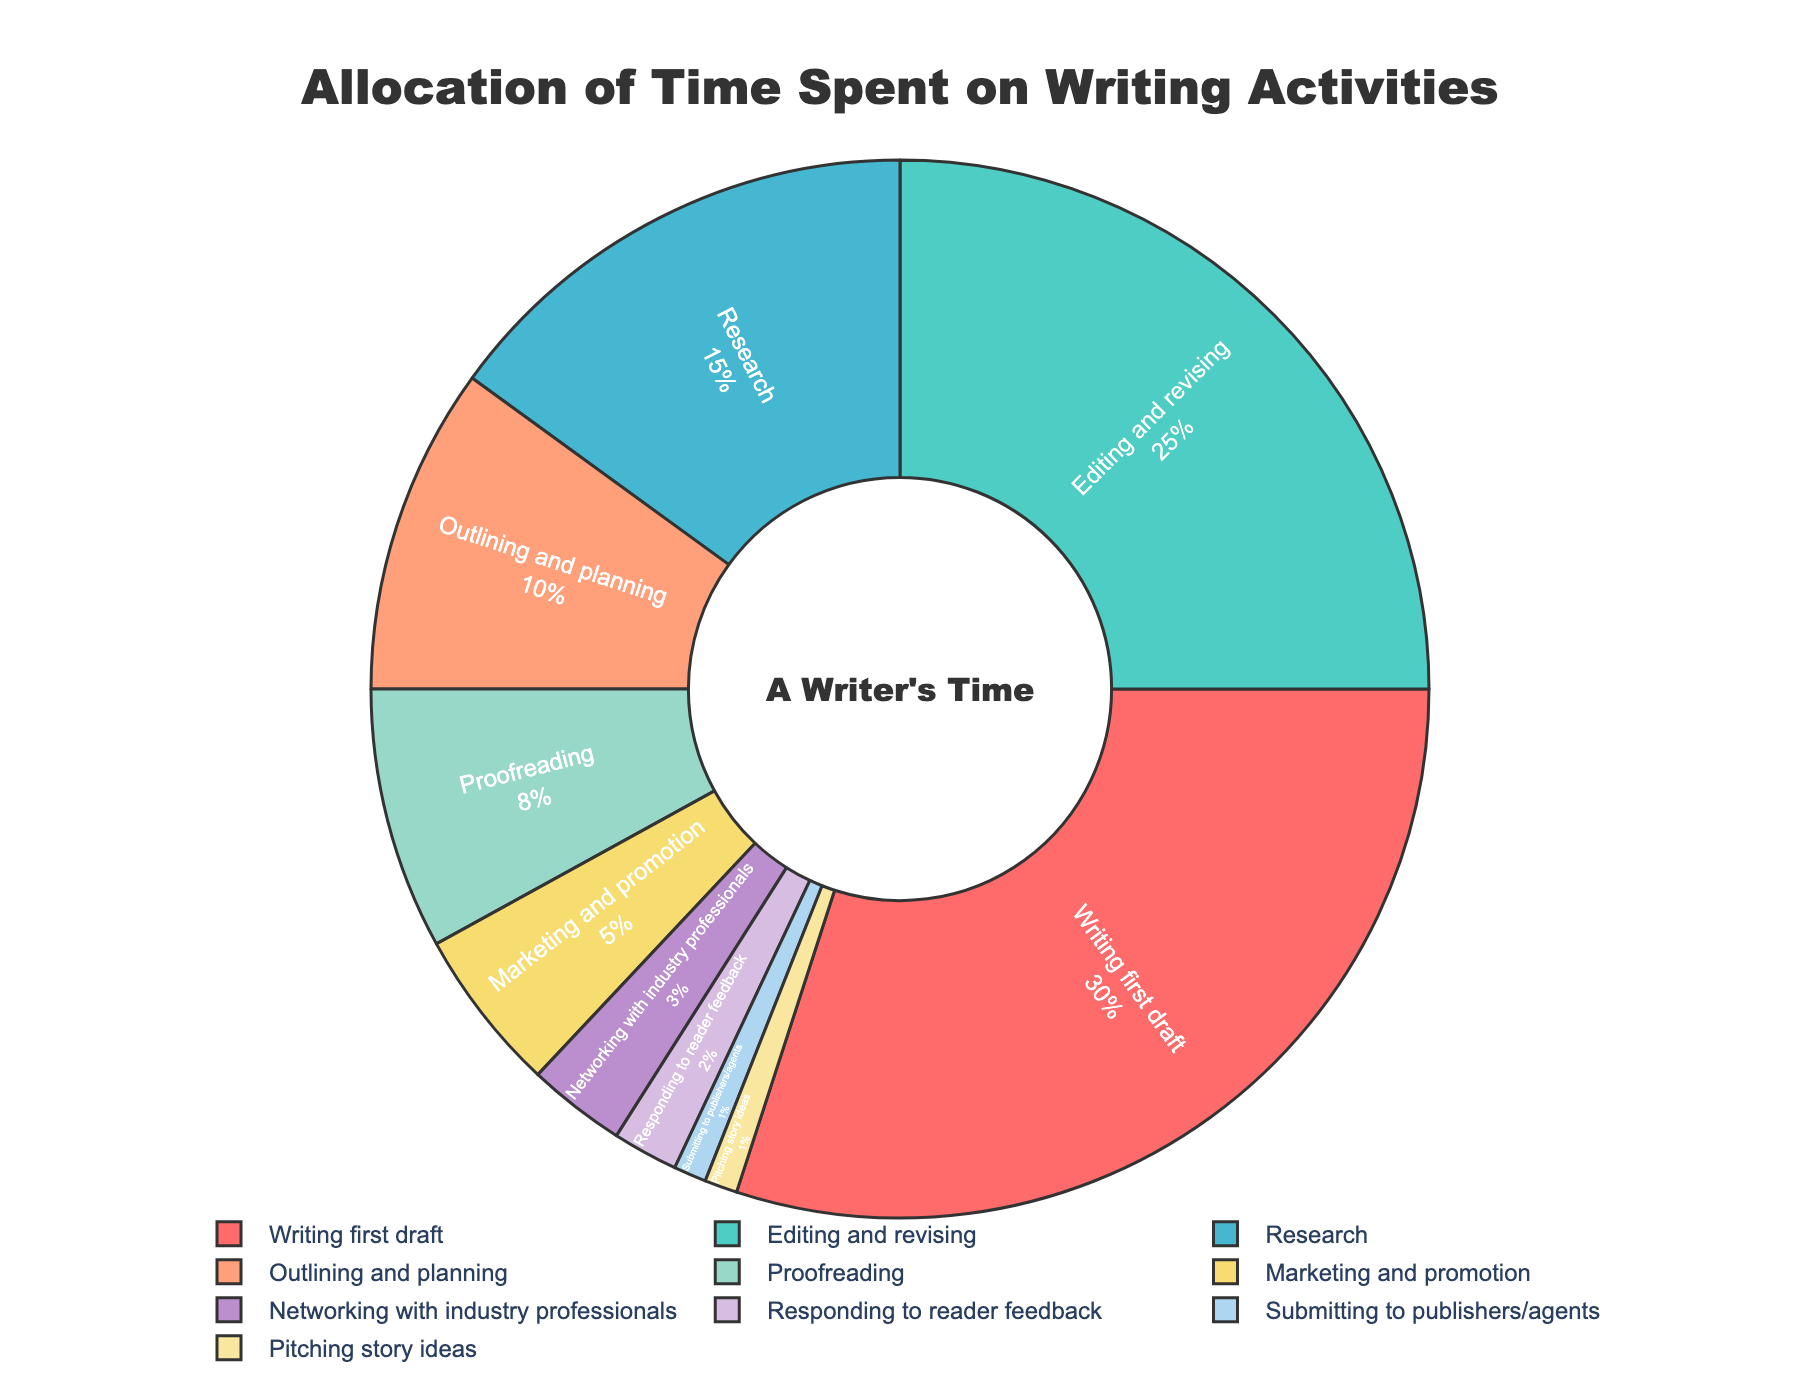What is the largest portion of the pie chart representing? The largest portion of the pie chart represents "Writing first draft," which takes up 30% of the total time.
Answer: Writing first draft Which activity takes up a quarter of the time? "Editing and revising" takes up 25% of the total time. This is 25%, which is one-quarter of 100%.
Answer: Editing and revising How much more time is spent on editing and revising compared to marketing and promotion? The percentage of time spent on editing and revising is 25%, and on marketing and promotion is 5%. The difference is 25% - 5% = 20%.
Answer: 20% Which activities together take up the same amount of time as writing the first draft? "Editing and revising" (25%) plus "Networking with industry professionals" (3%) and "Responding to reader feedback" (2%) together take up 25% + 3% + 2% = 30%, which is equal to the time spent on writing the first draft.
Answer: Editing and revising, Networking with industry professionals, and Responding to reader feedback What percentage of the pie chart is dedicated to research and planning activities combined? "Research" takes up 15%, and "Outlining and planning" takes up 10%. Combined, they take up 15% + 10% = 25%.
Answer: 25% Which activities are represented by the smallest segments of the pie chart? The smallest segments of the pie chart represent "Submitting to publishers/agents" and "Pitching story ideas," each with 1%.
Answer: Submitting to publishers/agents and Pitching story ideas Is the time spent on proofreading more or less than the time spent on marketing and promotion? The time spent on proofreading (8%) is more than the time spent on marketing and promotion (5%).
Answer: More List the activities that combined are less than the time spent on proofreading. "Networking with industry professionals" (3%), "Responding to reader feedback" (2%), "Submitting to publishers/agents" (1%), and "Pitching story ideas" (1%) combined make up 3% + 2% + 1% + 1% = 7%, which is less than the 8% spent on proofreading.
Answer: Networking with industry professionals, Responding to reader feedback, Submitting to publishers/agents, Pitching story ideas What is the central annotation on the pie chart? The central annotation on the pie chart reads "A Writer's Time."
Answer: A Writer's Time 